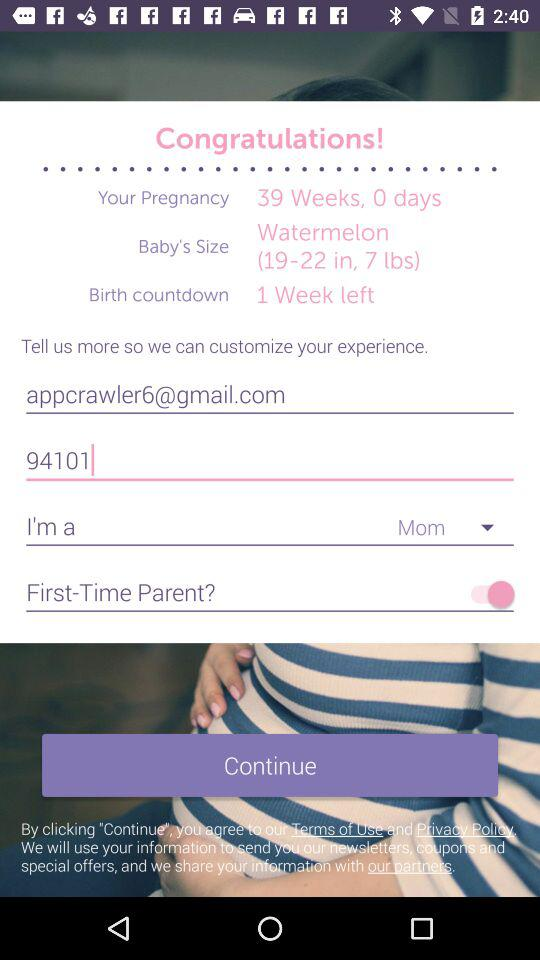What is the pregnancy period? The pregnancy period is 39 weeks and 0 days. 